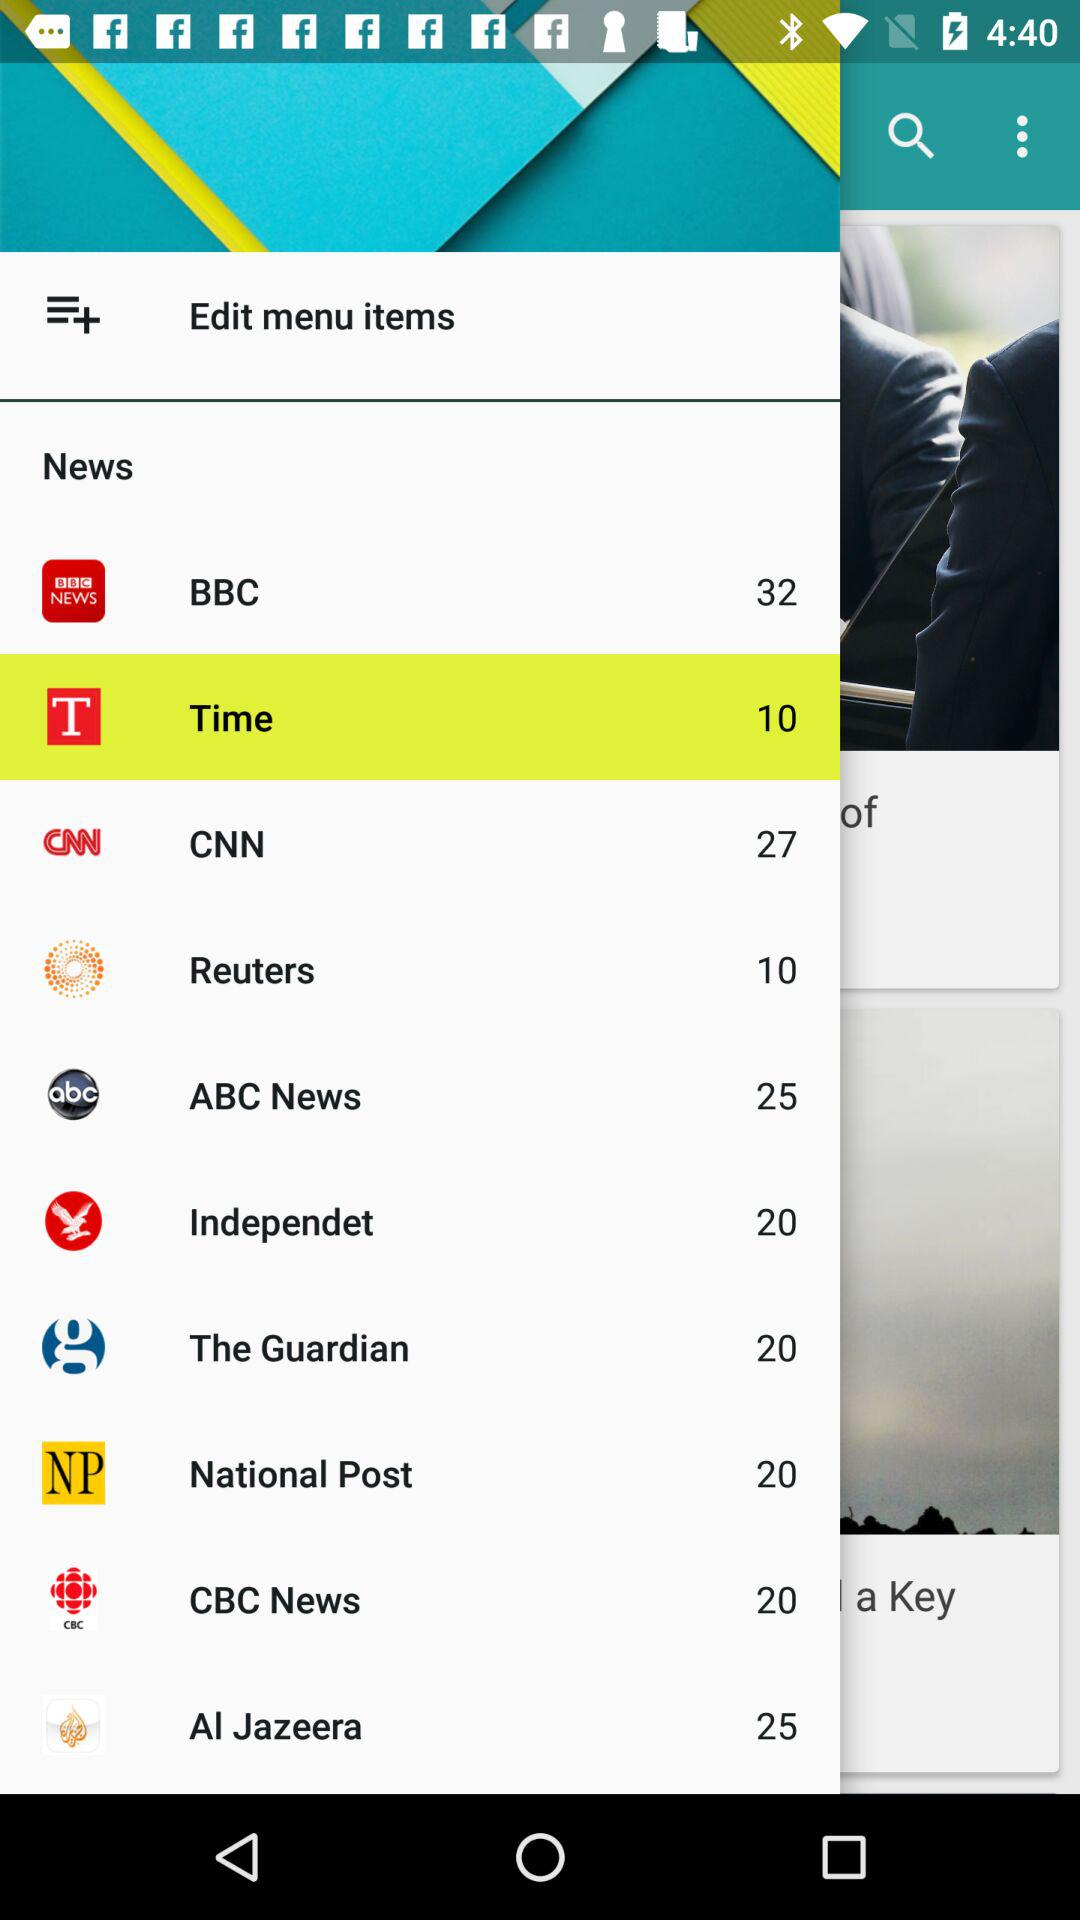What is the number shown for BBC? The shown number for BBC is 32. 